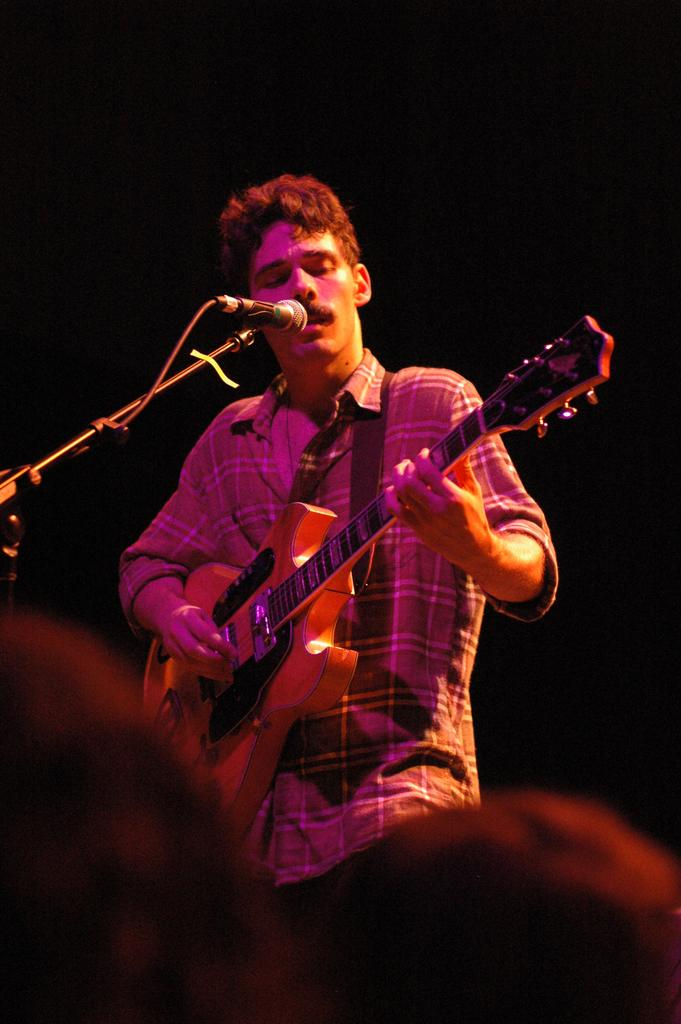What is the main subject of the image? There is a person in the image. What is the person doing in the image? The person is playing a guitar and standing in front of a mic. What is the person wearing in the image? The person is wearing clothes. Where is the cushion placed in the image? There is no cushion present in the image. What type of hen can be seen in the image? There is no hen present in the image. 